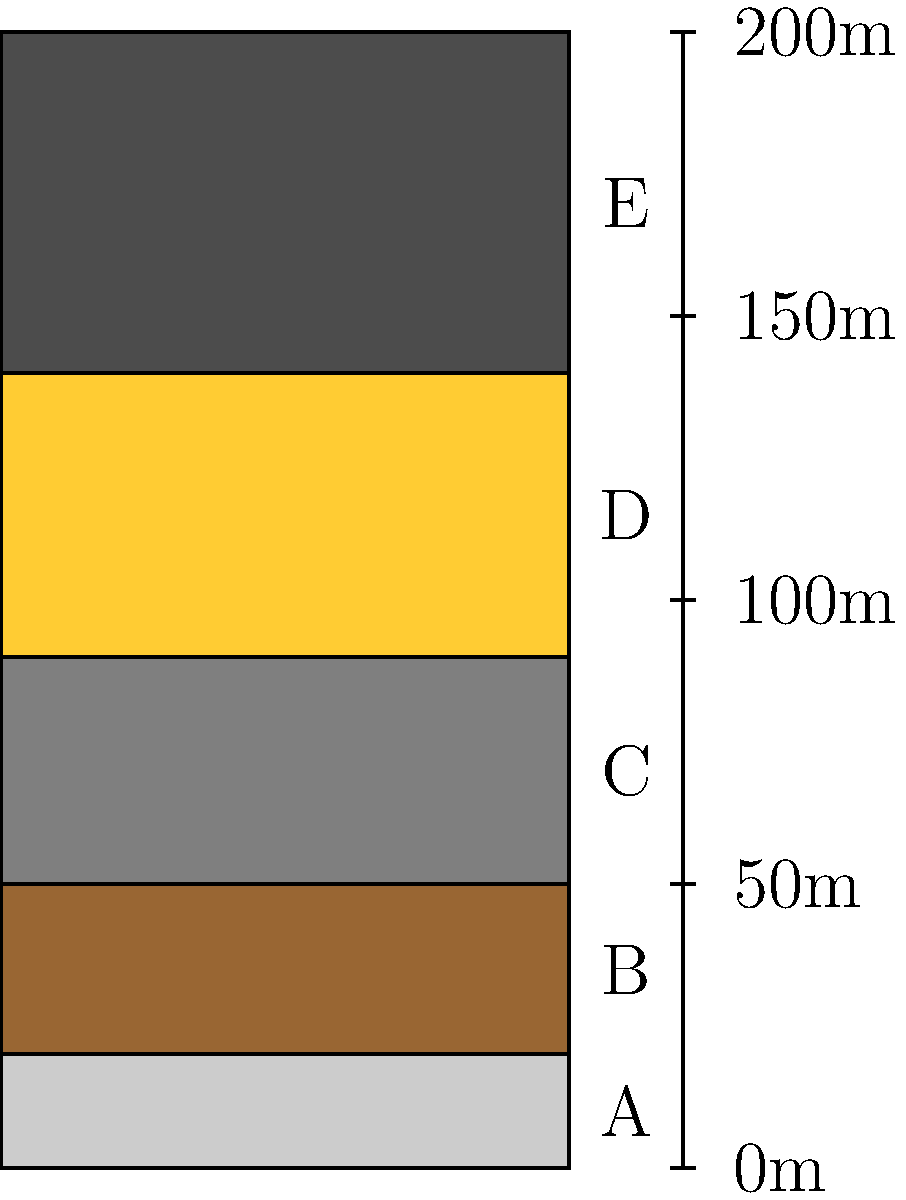In the geological cross-section shown above, which rock layer is most likely to contain fossil fuels, and why is this layer particularly promising for exploration? To answer this question, we need to analyze the rock layers presented in the cross-section and consider their potential for containing fossil fuels. Let's examine each layer:

1. Layer A (bottom): Light gray, likely limestone. While limestone can sometimes contain oil and gas, it's not the primary target for fossil fuel exploration.

2. Layer B: Brown, likely sandstone. Sandstone is a common reservoir rock for oil and gas, but we need to consider other factors.

3. Layer C: Medium gray, likely shale. Shale can be both a source rock for hydrocarbons and a reservoir in some cases (e.g., shale gas).

4. Layer D: Yellow, likely another sandstone layer. Again, a potential reservoir rock.

5. Layer E (top): Dark gray or black, likely coal. Coal is a fossil fuel itself and is often associated with natural gas (coalbed methane).

Among these layers, Layer E (coal) is the most promising for fossil fuel exploration because:

1. Coal is a fossil fuel: It's formed from the remains of plants that lived millions of years ago, compressed and altered by heat and pressure.

2. Associated natural gas: Coal seams often contain significant amounts of methane (natural gas) adsorbed onto the coal surface or trapped in fractures.

3. Indicator of past environments: The presence of coal indicates a past environment rich in organic material, which is essential for the formation of other fossil fuels like oil and natural gas.

4. Potential for multiple resources: In addition to the coal itself, the surrounding rocks (especially the sandstone in Layer D) may contain oil or gas that migrated from the coal or other source rocks.

5. Exploration potential: The coal layer's clear presence in the cross-section makes it an obvious target for further exploration and potential extraction of both coal and coalbed methane.
Answer: Layer E (coal) 